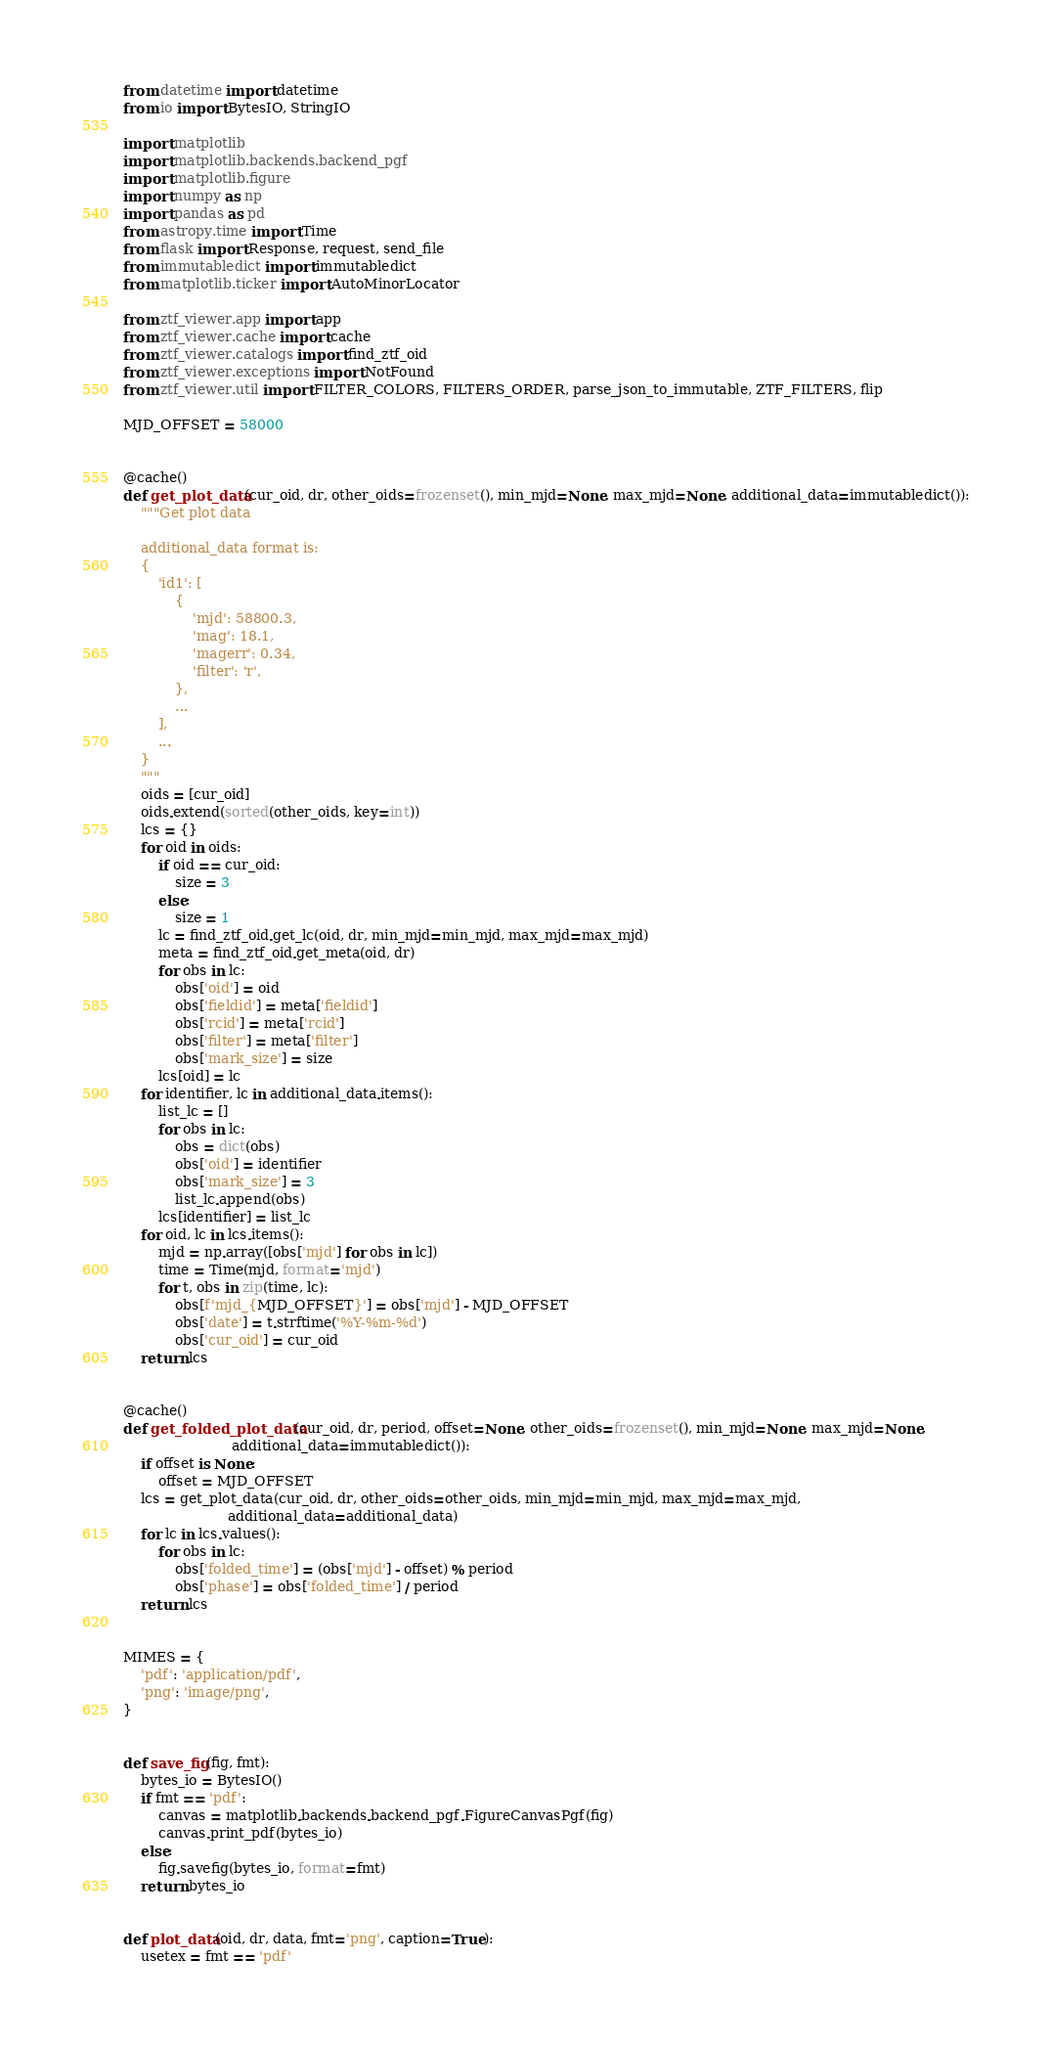Convert code to text. <code><loc_0><loc_0><loc_500><loc_500><_Python_>from datetime import datetime
from io import BytesIO, StringIO

import matplotlib
import matplotlib.backends.backend_pgf
import matplotlib.figure
import numpy as np
import pandas as pd
from astropy.time import Time
from flask import Response, request, send_file
from immutabledict import immutabledict
from matplotlib.ticker import AutoMinorLocator

from ztf_viewer.app import app
from ztf_viewer.cache import cache
from ztf_viewer.catalogs import find_ztf_oid
from ztf_viewer.exceptions import NotFound
from ztf_viewer.util import FILTER_COLORS, FILTERS_ORDER, parse_json_to_immutable, ZTF_FILTERS, flip

MJD_OFFSET = 58000


@cache()
def get_plot_data(cur_oid, dr, other_oids=frozenset(), min_mjd=None, max_mjd=None, additional_data=immutabledict()):
    """Get plot data

    additional_data format is:
    {
        'id1': [
            {
                'mjd': 58800.3,
                'mag': 18.1,
                'magerr': 0.34,
                'filter': 'r',
            },
            ...
        ],
        ...
    }
    """
    oids = [cur_oid]
    oids.extend(sorted(other_oids, key=int))
    lcs = {}
    for oid in oids:
        if oid == cur_oid:
            size = 3
        else:
            size = 1
        lc = find_ztf_oid.get_lc(oid, dr, min_mjd=min_mjd, max_mjd=max_mjd)
        meta = find_ztf_oid.get_meta(oid, dr)
        for obs in lc:
            obs['oid'] = oid
            obs['fieldid'] = meta['fieldid']
            obs['rcid'] = meta['rcid']
            obs['filter'] = meta['filter']
            obs['mark_size'] = size
        lcs[oid] = lc
    for identifier, lc in additional_data.items():
        list_lc = []
        for obs in lc:
            obs = dict(obs)
            obs['oid'] = identifier
            obs['mark_size'] = 3
            list_lc.append(obs)
        lcs[identifier] = list_lc
    for oid, lc in lcs.items():
        mjd = np.array([obs['mjd'] for obs in lc])
        time = Time(mjd, format='mjd')
        for t, obs in zip(time, lc):
            obs[f'mjd_{MJD_OFFSET}'] = obs['mjd'] - MJD_OFFSET
            obs['date'] = t.strftime('%Y-%m-%d')
            obs['cur_oid'] = cur_oid
    return lcs


@cache()
def get_folded_plot_data(cur_oid, dr, period, offset=None, other_oids=frozenset(), min_mjd=None, max_mjd=None,
                         additional_data=immutabledict()):
    if offset is None:
        offset = MJD_OFFSET
    lcs = get_plot_data(cur_oid, dr, other_oids=other_oids, min_mjd=min_mjd, max_mjd=max_mjd,
                        additional_data=additional_data)
    for lc in lcs.values():
        for obs in lc:
            obs['folded_time'] = (obs['mjd'] - offset) % period
            obs['phase'] = obs['folded_time'] / period
    return lcs


MIMES = {
    'pdf': 'application/pdf',
    'png': 'image/png',
}


def save_fig(fig, fmt):
    bytes_io = BytesIO()
    if fmt == 'pdf':
        canvas = matplotlib.backends.backend_pgf.FigureCanvasPgf(fig)
        canvas.print_pdf(bytes_io)
    else:
        fig.savefig(bytes_io, format=fmt)
    return bytes_io


def plot_data(oid, dr, data, fmt='png', caption=True):
    usetex = fmt == 'pdf'
</code> 